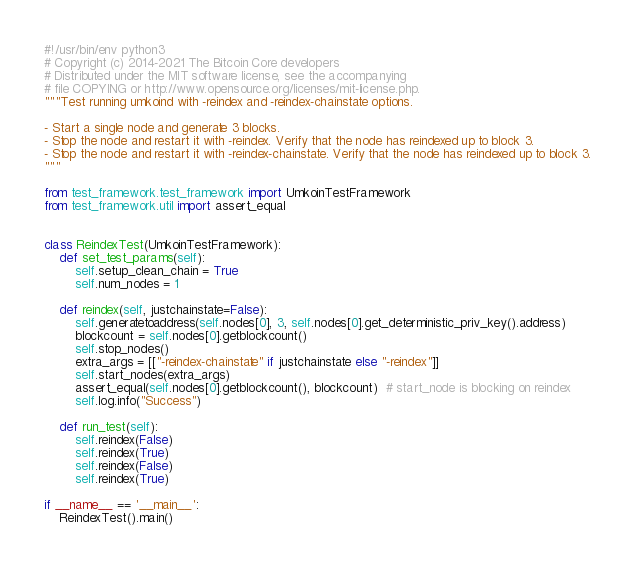<code> <loc_0><loc_0><loc_500><loc_500><_Python_>#!/usr/bin/env python3
# Copyright (c) 2014-2021 The Bitcoin Core developers
# Distributed under the MIT software license, see the accompanying
# file COPYING or http://www.opensource.org/licenses/mit-license.php.
"""Test running umkoind with -reindex and -reindex-chainstate options.

- Start a single node and generate 3 blocks.
- Stop the node and restart it with -reindex. Verify that the node has reindexed up to block 3.
- Stop the node and restart it with -reindex-chainstate. Verify that the node has reindexed up to block 3.
"""

from test_framework.test_framework import UmkoinTestFramework
from test_framework.util import assert_equal


class ReindexTest(UmkoinTestFramework):
    def set_test_params(self):
        self.setup_clean_chain = True
        self.num_nodes = 1

    def reindex(self, justchainstate=False):
        self.generatetoaddress(self.nodes[0], 3, self.nodes[0].get_deterministic_priv_key().address)
        blockcount = self.nodes[0].getblockcount()
        self.stop_nodes()
        extra_args = [["-reindex-chainstate" if justchainstate else "-reindex"]]
        self.start_nodes(extra_args)
        assert_equal(self.nodes[0].getblockcount(), blockcount)  # start_node is blocking on reindex
        self.log.info("Success")

    def run_test(self):
        self.reindex(False)
        self.reindex(True)
        self.reindex(False)
        self.reindex(True)

if __name__ == '__main__':
    ReindexTest().main()
</code> 